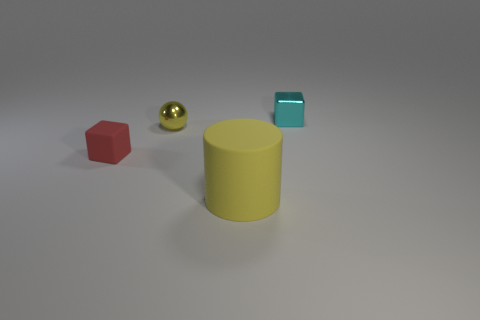There is a thing that is made of the same material as the small yellow sphere; what is its color?
Your answer should be compact. Cyan. Is the size of the block that is to the left of the ball the same as the yellow sphere?
Give a very brief answer. Yes. Is the material of the big cylinder the same as the tiny ball that is on the right side of the red object?
Your response must be concise. No. The rubber thing that is behind the big yellow matte cylinder is what color?
Offer a terse response. Red. Are there any small red matte objects that are behind the metallic thing that is to the left of the cyan object?
Give a very brief answer. No. Is the color of the tiny thing that is behind the yellow metallic sphere the same as the metal sphere that is to the right of the small red rubber object?
Your response must be concise. No. What number of small shiny cubes are behind the tiny cyan shiny block?
Offer a terse response. 0. How many tiny metallic things are the same color as the small matte cube?
Your answer should be very brief. 0. Is the small block to the right of the large yellow cylinder made of the same material as the small red thing?
Offer a terse response. No. What number of small red objects are the same material as the ball?
Your answer should be very brief. 0. 